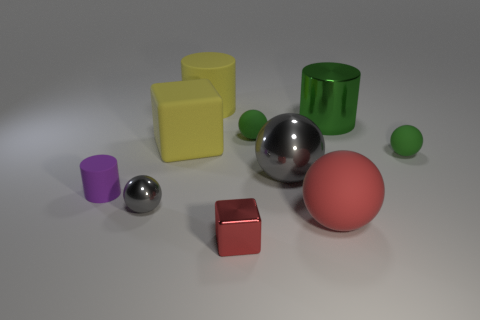Subtract all large rubber balls. How many balls are left? 4 Subtract all red balls. How many balls are left? 4 Subtract all blue balls. Subtract all purple blocks. How many balls are left? 5 Subtract all blocks. How many objects are left? 8 Add 3 red metallic objects. How many red metallic objects are left? 4 Add 7 large yellow matte cubes. How many large yellow matte cubes exist? 8 Subtract 0 blue spheres. How many objects are left? 10 Subtract all big cylinders. Subtract all large blue matte balls. How many objects are left? 8 